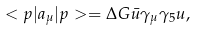<formula> <loc_0><loc_0><loc_500><loc_500>< p | a _ { \mu } | p > = \Delta G \bar { u } \gamma _ { \mu } \gamma _ { 5 } u ,</formula> 